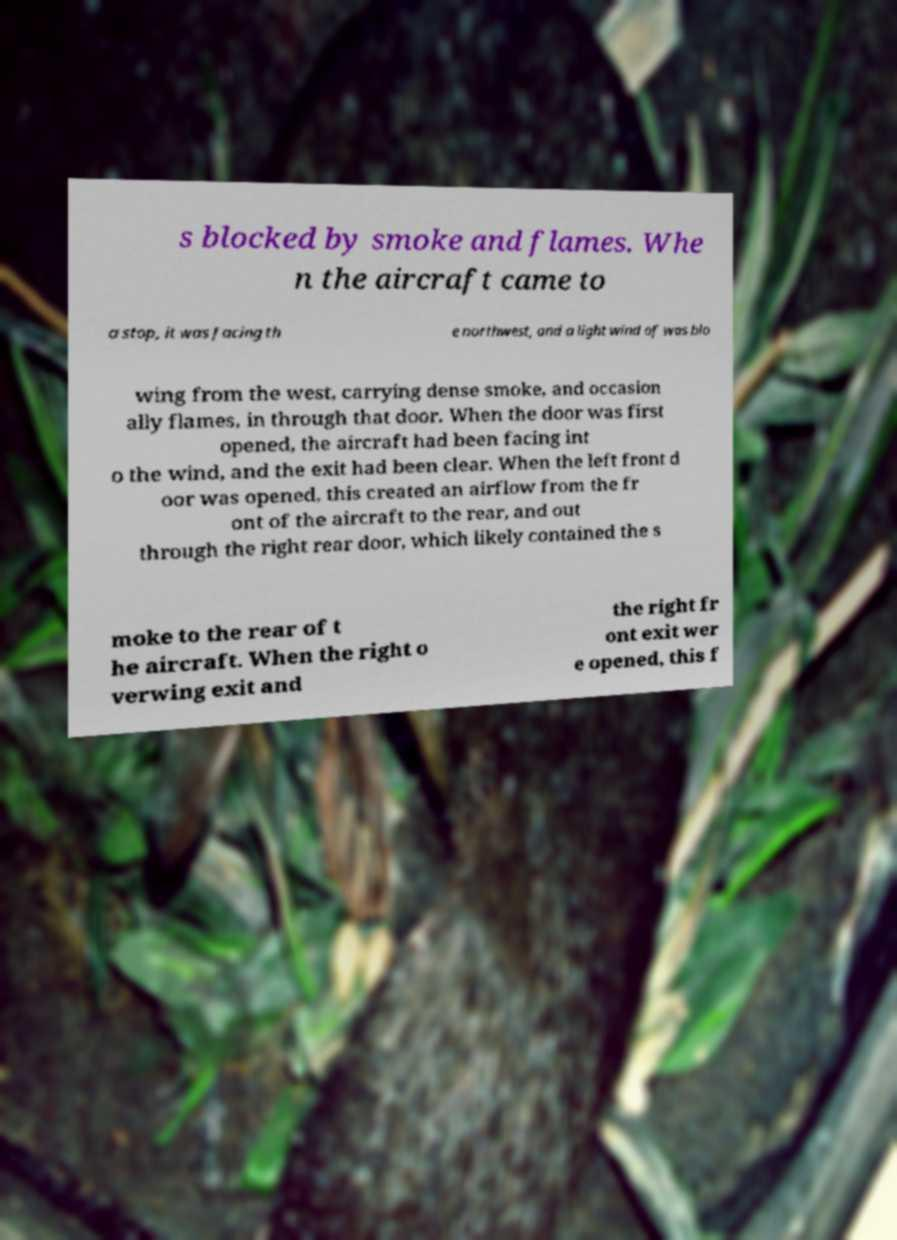Please read and relay the text visible in this image. What does it say? s blocked by smoke and flames. Whe n the aircraft came to a stop, it was facing th e northwest, and a light wind of was blo wing from the west, carrying dense smoke, and occasion ally flames, in through that door. When the door was first opened, the aircraft had been facing int o the wind, and the exit had been clear. When the left front d oor was opened, this created an airflow from the fr ont of the aircraft to the rear, and out through the right rear door, which likely contained the s moke to the rear of t he aircraft. When the right o verwing exit and the right fr ont exit wer e opened, this f 